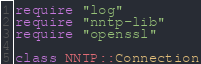Convert code to text. <code><loc_0><loc_0><loc_500><loc_500><_Crystal_>require "log"
require "nntp-lib"
require "openssl"

class NNTP::Connection</code> 